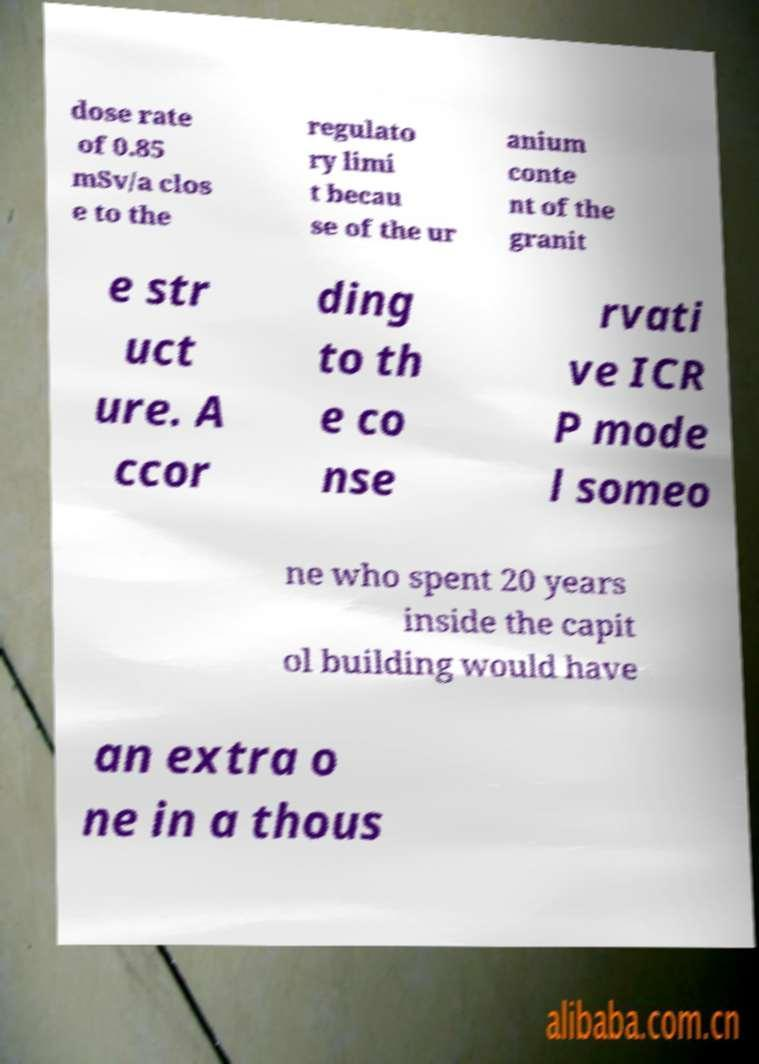Please identify and transcribe the text found in this image. dose rate of 0.85 mSv/a clos e to the regulato ry limi t becau se of the ur anium conte nt of the granit e str uct ure. A ccor ding to th e co nse rvati ve ICR P mode l someo ne who spent 20 years inside the capit ol building would have an extra o ne in a thous 